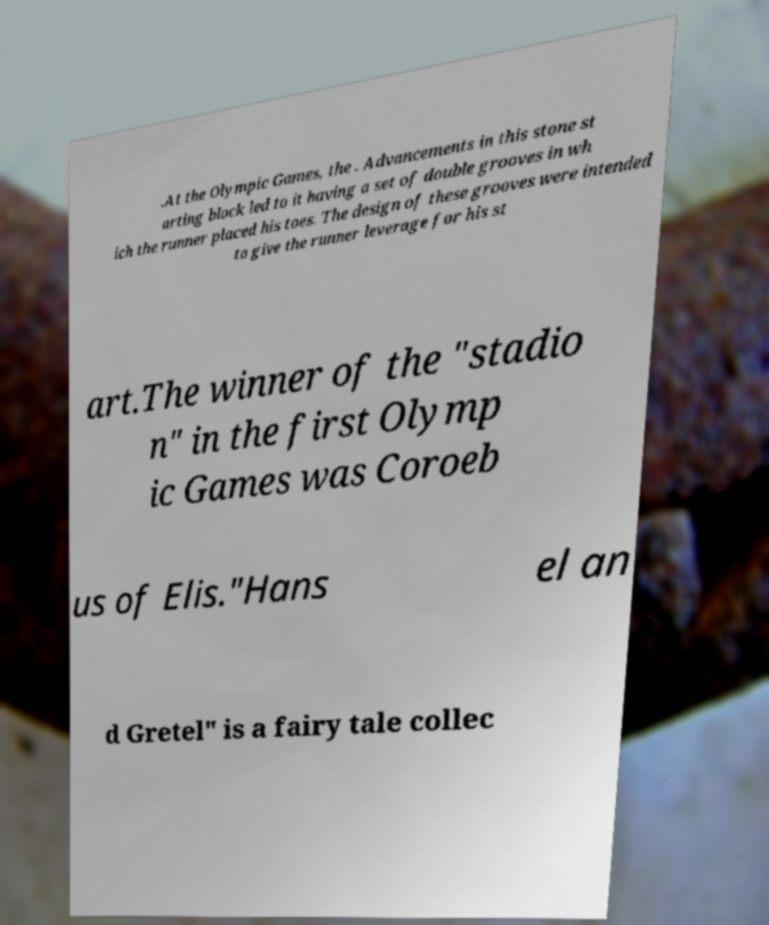Please identify and transcribe the text found in this image. .At the Olympic Games, the . Advancements in this stone st arting block led to it having a set of double grooves in wh ich the runner placed his toes. The design of these grooves were intended to give the runner leverage for his st art.The winner of the "stadio n" in the first Olymp ic Games was Coroeb us of Elis."Hans el an d Gretel" is a fairy tale collec 